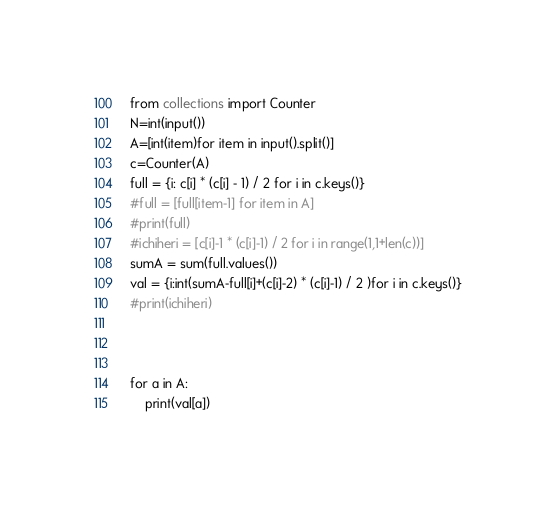Convert code to text. <code><loc_0><loc_0><loc_500><loc_500><_Python_>from collections import Counter
N=int(input())
A=[int(item)for item in input().split()]
c=Counter(A)
full = {i: c[i] * (c[i] - 1) / 2 for i in c.keys()}
#full = [full[item-1] for item in A]
#print(full)
#ichiheri = [c[i]-1 * (c[i]-1) / 2 for i in range(1,1+len(c))]
sumA = sum(full.values())
val = {i:int(sumA-full[i]+(c[i]-2) * (c[i]-1) / 2 )for i in c.keys()}
#print(ichiheri)



for a in A:
    print(val[a])</code> 